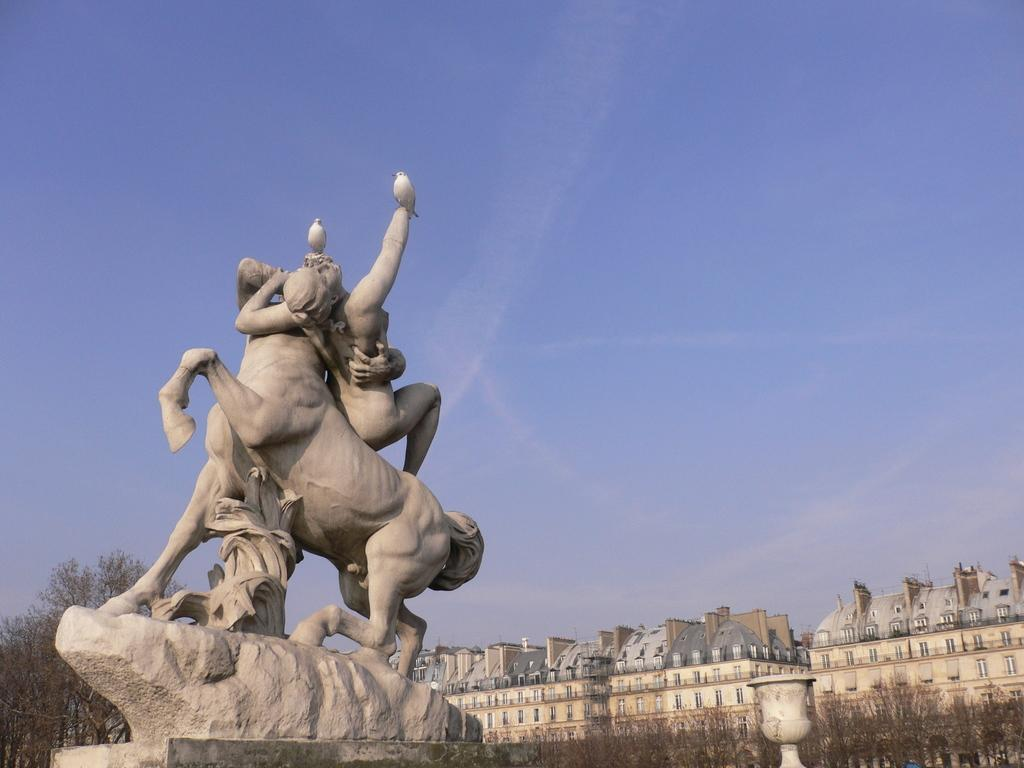What is the main subject in the image? There is a statue in the image. Where is the statue located? The statue is located towards the left side of the image. What is on the statue? There are two birds on the statue. What can be seen at the bottom right of the image? There are buildings and trees at the bottom right of the image. What is visible at the top of the image? The sky is visible at the top of the image. What can be observed in the sky? Clouds are present in the sky. What type of sack is being used by the birds on the statue? There are no sacks present in the image, as the birds are not using any sacks. 